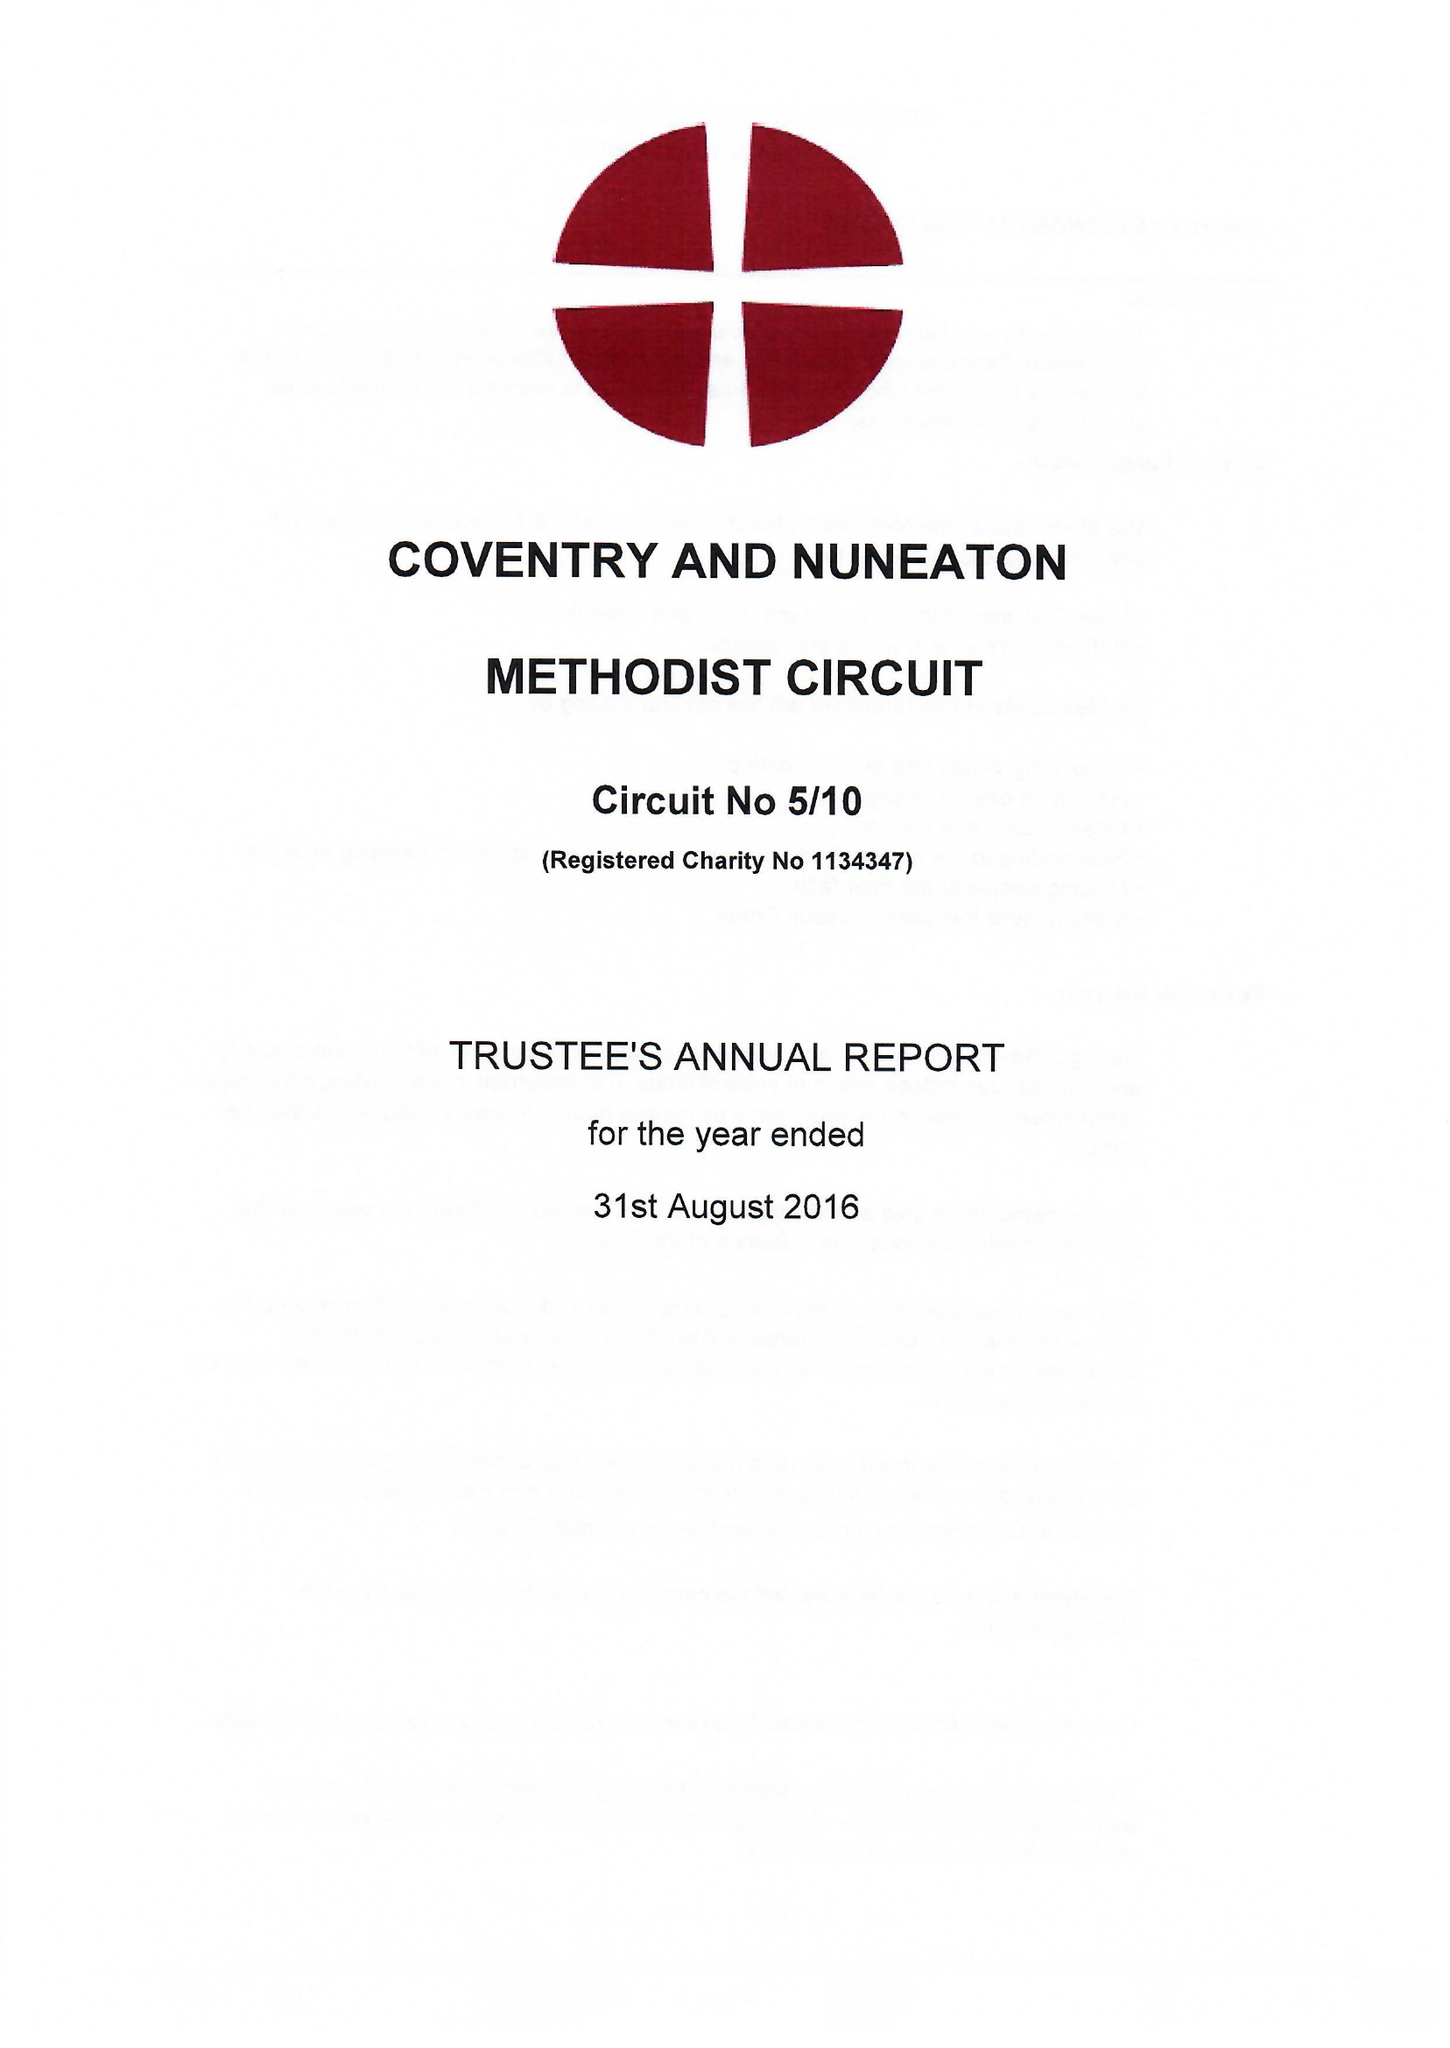What is the value for the address__post_town?
Answer the question using a single word or phrase. COVENTRY 